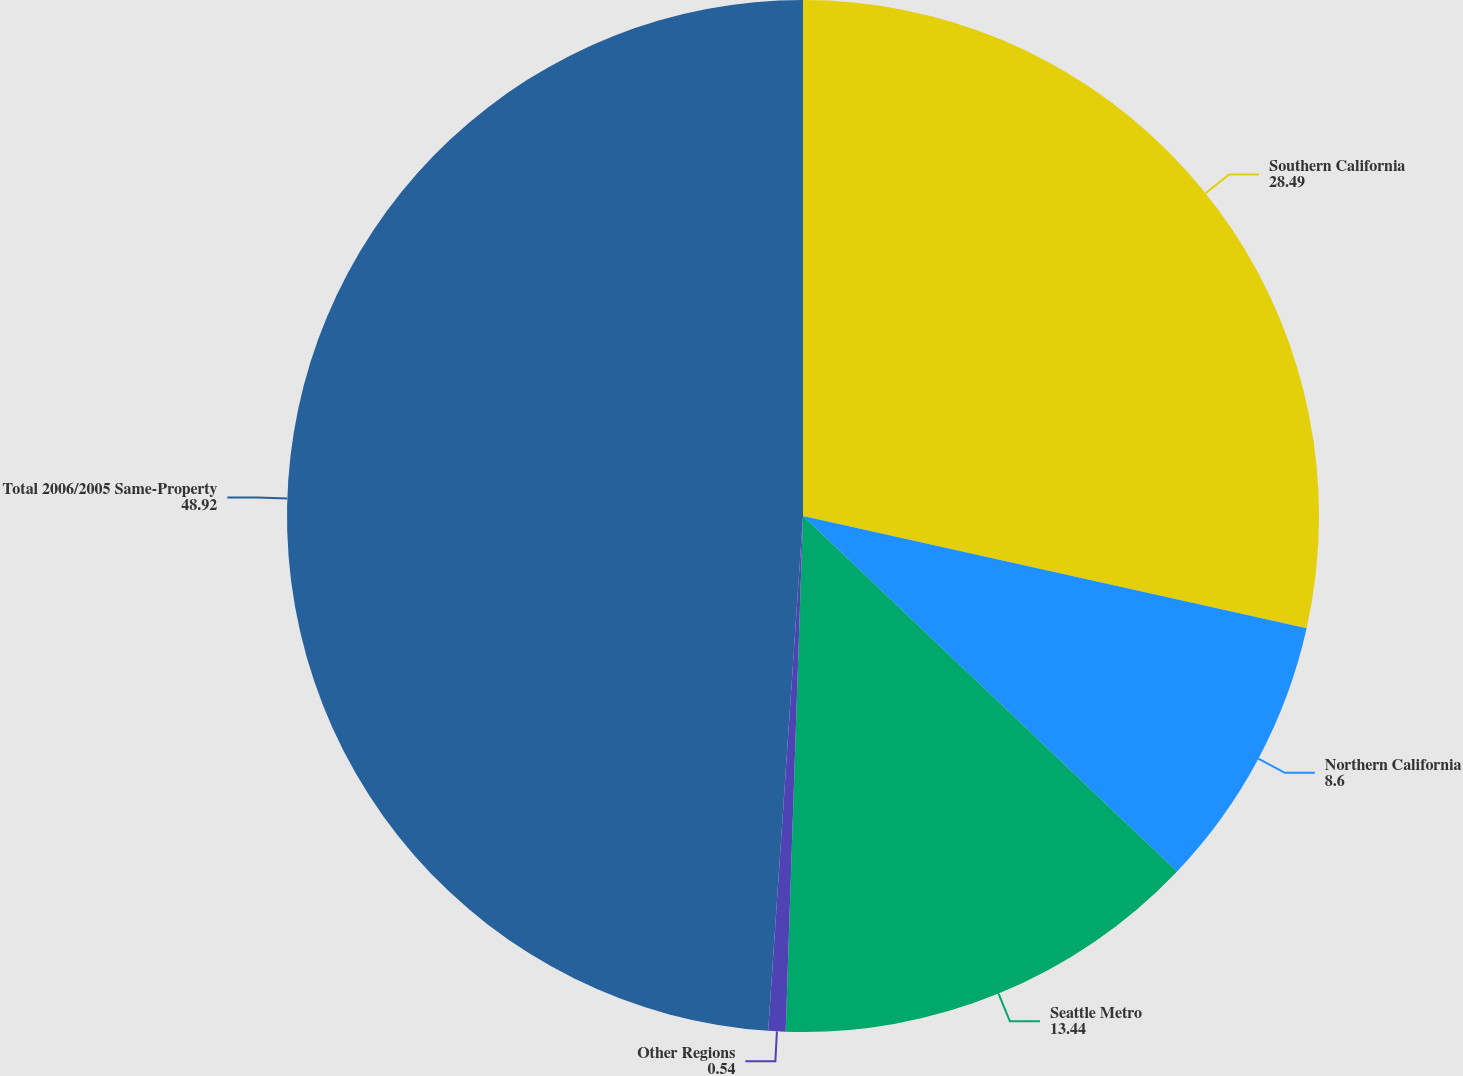<chart> <loc_0><loc_0><loc_500><loc_500><pie_chart><fcel>Southern California<fcel>Northern California<fcel>Seattle Metro<fcel>Other Regions<fcel>Total 2006/2005 Same-Property<nl><fcel>28.49%<fcel>8.6%<fcel>13.44%<fcel>0.54%<fcel>48.92%<nl></chart> 